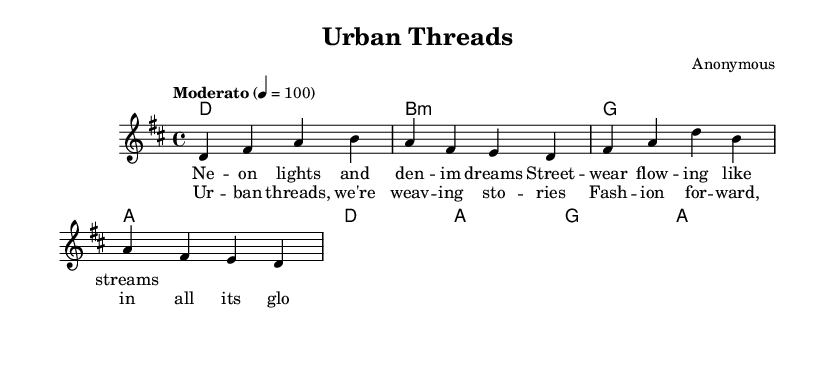What is the title of this music? The title is found in the header of the sheet music. It states "Urban Threads" prominently.
Answer: Urban Threads What is the key signature of this music? The key signature is determined by the key indication found before the staff, which here shows "d" indicating D major, consisting of two sharps (F# and C#).
Answer: D major What is the time signature of this music? The time signature is present just after the key signature; here it reads "4/4," indicating four beats per measure.
Answer: 4/4 How many measures are there in the melody? The melody section consists of a set of individual measures; counting them shows there are four complete measures.
Answer: 4 What is the tempo marking for this piece? The tempo marking is included near the top of the score, stating "Moderato" with a metronome indication of 100 beats per minute.
Answer: Moderato What is the genre of this music? The genre can be derived from the title "Urban Threads" and the lyrics, which focus on themes commonly associated with contemporary folk music, integrating elements of urban fashion.
Answer: Folk What is the primary theme of the lyrics in this song? The primary theme can be derived from the lyrics; they reference street wear and urban fashion, implying a narrative about contemporary fashion trends in urban settings.
Answer: Urban fashion 